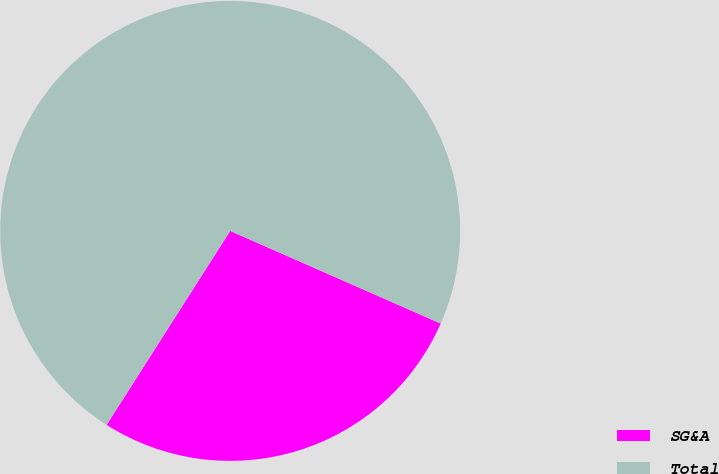Convert chart to OTSL. <chart><loc_0><loc_0><loc_500><loc_500><pie_chart><fcel>SG&A<fcel>Total<nl><fcel>27.43%<fcel>72.57%<nl></chart> 